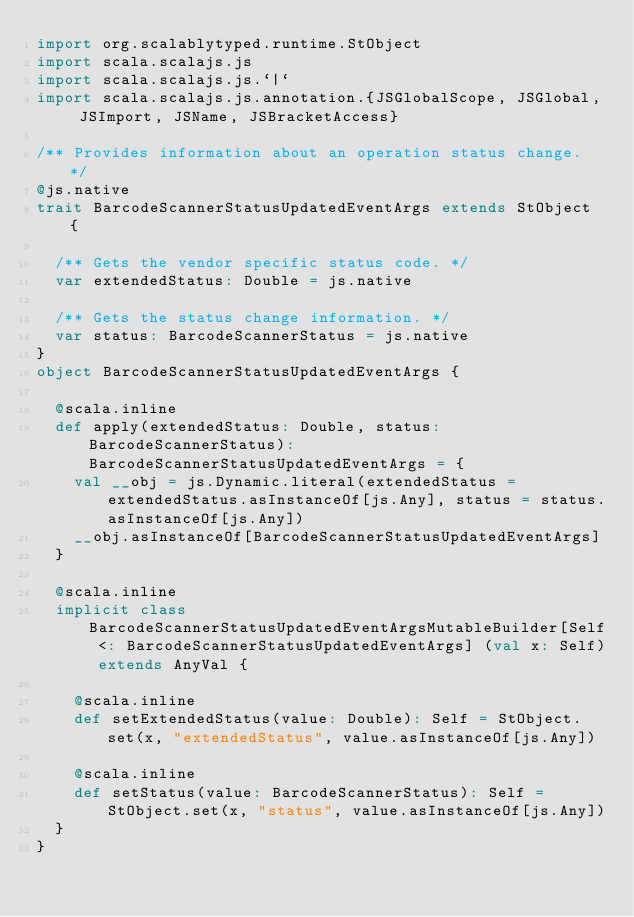Convert code to text. <code><loc_0><loc_0><loc_500><loc_500><_Scala_>import org.scalablytyped.runtime.StObject
import scala.scalajs.js
import scala.scalajs.js.`|`
import scala.scalajs.js.annotation.{JSGlobalScope, JSGlobal, JSImport, JSName, JSBracketAccess}

/** Provides information about an operation status change. */
@js.native
trait BarcodeScannerStatusUpdatedEventArgs extends StObject {
  
  /** Gets the vendor specific status code. */
  var extendedStatus: Double = js.native
  
  /** Gets the status change information. */
  var status: BarcodeScannerStatus = js.native
}
object BarcodeScannerStatusUpdatedEventArgs {
  
  @scala.inline
  def apply(extendedStatus: Double, status: BarcodeScannerStatus): BarcodeScannerStatusUpdatedEventArgs = {
    val __obj = js.Dynamic.literal(extendedStatus = extendedStatus.asInstanceOf[js.Any], status = status.asInstanceOf[js.Any])
    __obj.asInstanceOf[BarcodeScannerStatusUpdatedEventArgs]
  }
  
  @scala.inline
  implicit class BarcodeScannerStatusUpdatedEventArgsMutableBuilder[Self <: BarcodeScannerStatusUpdatedEventArgs] (val x: Self) extends AnyVal {
    
    @scala.inline
    def setExtendedStatus(value: Double): Self = StObject.set(x, "extendedStatus", value.asInstanceOf[js.Any])
    
    @scala.inline
    def setStatus(value: BarcodeScannerStatus): Self = StObject.set(x, "status", value.asInstanceOf[js.Any])
  }
}
</code> 